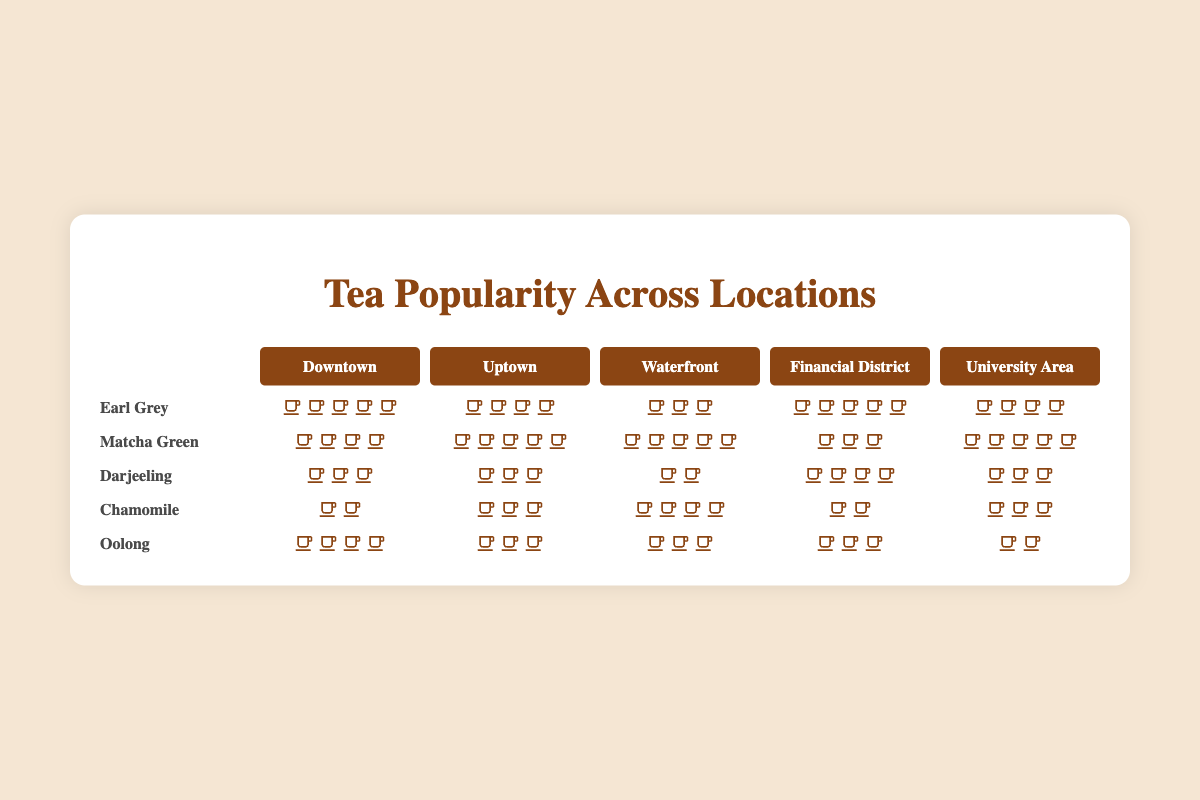What's the most popular tea variety at the Downtown location? Count the number of cup icons for each tea variety in the Downtown column. Earl Grey has 5 cups, Matcha Green has 4 cups, Darjeeling has 3 cups, Chamomile has 2 cups, and Oolong has 4 cups. Earl Grey has the highest count.
Answer: Earl Grey Which location has the highest popularity for Matcha Green tea? Count the number of cup icons for Matcha Green across all locations. Downtown has 4 cups, Uptown has 5 cups, Waterfront has 5 cups, Financial District has 3 cups, and University Area has 5 cups. Waterfront, Uptown, and University Area all have the highest count of 5.
Answer: Waterfront, Uptown, University Area How many cups in total are there for Darjeeling across all locations? Count the number of cup icons for Darjeeling in each location: Downtown has 3 cups, Uptown has 3 cups, Waterfront has 2 cups, Financial District has 4 cups, and University Area has 3 cups. Add them up: 3 + 3 + 2 + 4 + 3 = 15.
Answer: 15 Which tea variety is the least popular in the Financial District? Count the number of cup icons for each tea variety in the Financial District column. Earl Grey has 5 cups, Matcha Green has 3 cups, Darjeeling has 4 cups, Chamomile has 2 cups, and Oolong has 3 cups. Chamomile has the lowest count.
Answer: Chamomile Is Earl Grey more popular in the University Area or in Uptown? Compare the number of cup icons for Earl Grey in both University Area and Uptown. University Area has 4 cups, and Uptown has 4 cups. Since they are equal, it's not more popular in one than the other.
Answer: Equal What's the total number of cups for all tea varieties at the Waterfront location? Count the number of cup icons for all tea varieties at the Waterfront location: Earl Grey has 3 cups, Matcha Green has 5 cups, Darjeeling has 2 cups, Chamomile has 4 cups, and Oolong has 3 cups. Add them up: 3 + 5 + 2 + 4 + 3 = 17.
Answer: 17 Which tea variety is the most evenly distributed across all locations? Compare the number of cup icons for each tea variety across all locations. Earl Grey (5, 4, 3, 5, 4) ranges between 3-5, Matcha Green (4, 5, 5, 3, 5) ranges between 3-5, Darjeeling (3, 3, 2, 4, 3) ranges between 2-4, Chamomile (2, 3, 4, 2, 3) ranges between 2-4, and Oolong (4, 3, 3, 3, 2) ranges between 2-4. Earl Grey and Matcha Green have the narrowest range, but Matcha Green's range covers more locations evenly.
Answer: Matcha Green How many more cups of Earl Grey are sold in the Financial District compared to Waterfront? Count the number of cup icons for Earl Grey in Financial District (5 cups) and Waterfront (3 cups). Subtract the Waterfrom count from Financial District count: 5 - 3 = 2.
Answer: 2 Which location has the least variety in tea popularity? Count the unique numbers of cup icons for each location. Downtown: 2 (4 types), Uptown: 4 (5 types), Waterfront: 2 (4 types), Financial District: 4 (5 types), University Area: 3 (5 types). The location with the smallest number of unique counts is the one with the least variety.
Answer: Downtown 